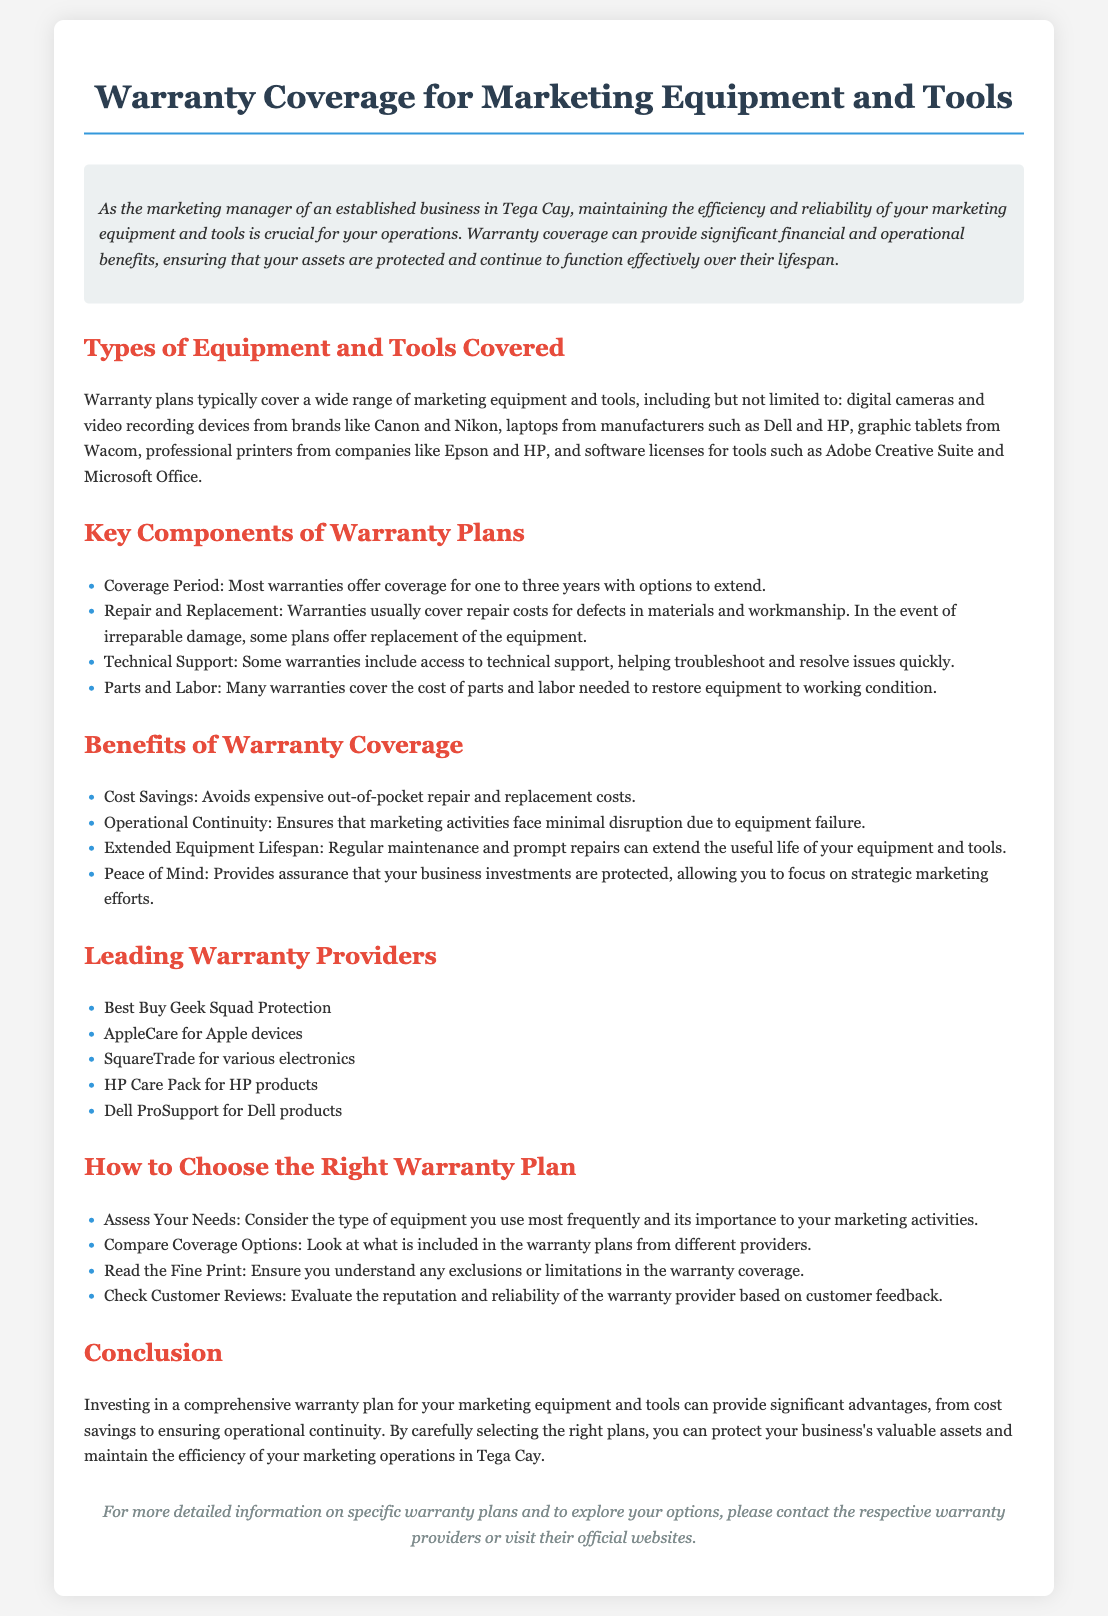What types of equipment are typically covered? The document lists specific types of marketing equipment and tools that are typically covered under warranty plans.
Answer: digital cameras, laptops, graphic tablets, printers, software licenses What is the coverage period for most warranties? The coverage period is mentioned as a standard range provided in the document.
Answer: one to three years What benefit does warranty coverage provide regarding costs? The document highlights a specific financial advantage of warranty coverage.
Answer: Cost Savings Which warranty provider is mentioned for Apple devices? The name of the provider is specifically listed in the section about leading warranty providers.
Answer: AppleCare What should you assess when choosing a warranty plan? The document outlines a specific action to take when selecting a warranty plan.
Answer: Assess Your Needs What does warranty coverage ensure for marketing activities? The impact of warranty coverage on operations is detailed in the benefits section of the document.
Answer: Operational Continuity How many warranty providers are listed in the document? The total number of providers mentioned in the document is directly countable.
Answer: Five What type of support may be included in some warranty plans? The document specifies a type of assistance that may come with warranty coverage.
Answer: Technical Support What is a key component of warranty plans regarding equipment condition? The document refers to actions taken for equipment issues under warranty plans.
Answer: Repair and Replacement 